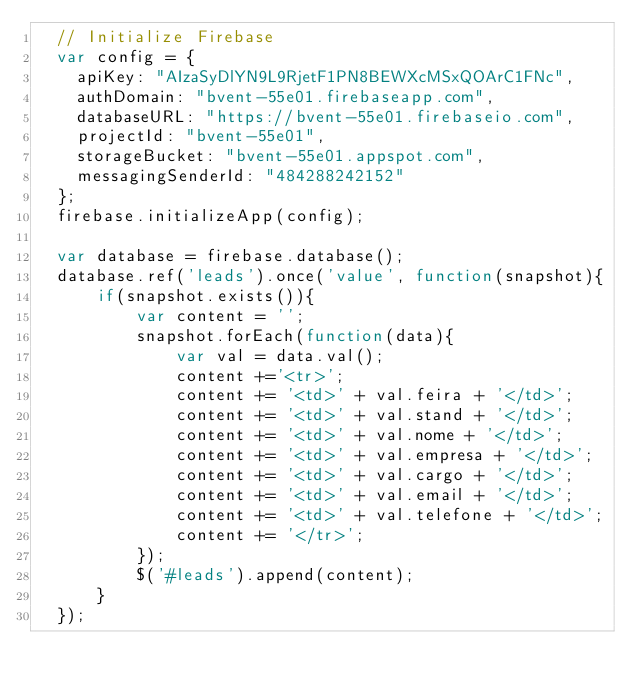Convert code to text. <code><loc_0><loc_0><loc_500><loc_500><_JavaScript_>  // Initialize Firebase
  var config = {
    apiKey: "AIzaSyDlYN9L9RjetF1PN8BEWXcMSxQOArC1FNc",
    authDomain: "bvent-55e01.firebaseapp.com",
    databaseURL: "https://bvent-55e01.firebaseio.com",
    projectId: "bvent-55e01",
    storageBucket: "bvent-55e01.appspot.com",
    messagingSenderId: "484288242152"
  };
  firebase.initializeApp(config);

  var database = firebase.database();
  database.ref('leads').once('value', function(snapshot){
      if(snapshot.exists()){
          var content = '';
          snapshot.forEach(function(data){
              var val = data.val();
              content +='<tr>';
              content += '<td>' + val.feira + '</td>';
              content += '<td>' + val.stand + '</td>';
              content += '<td>' + val.nome + '</td>';
              content += '<td>' + val.empresa + '</td>';
              content += '<td>' + val.cargo + '</td>';
              content += '<td>' + val.email + '</td>';
              content += '<td>' + val.telefone + '</td>';
              content += '</tr>';
          });
          $('#leads').append(content);
      }
  });</code> 